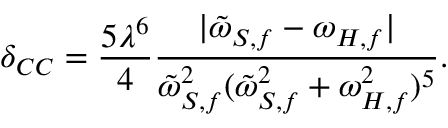Convert formula to latex. <formula><loc_0><loc_0><loc_500><loc_500>\delta _ { C C } = \frac { 5 \lambda ^ { 6 } } { 4 } \frac { | \tilde { \omega } _ { S , f } - \omega _ { H , f } | } { \tilde { \omega } _ { S , f } ^ { 2 } ( \tilde { \omega } _ { S , f } ^ { 2 } + \omega _ { H , f } ^ { 2 } ) ^ { 5 } } .</formula> 